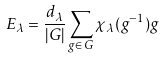Convert formula to latex. <formula><loc_0><loc_0><loc_500><loc_500>E _ { \lambda } = \frac { d _ { \lambda } } { | G | } \sum _ { g \in \, G } \chi _ { \lambda } ( g ^ { - 1 } ) g</formula> 